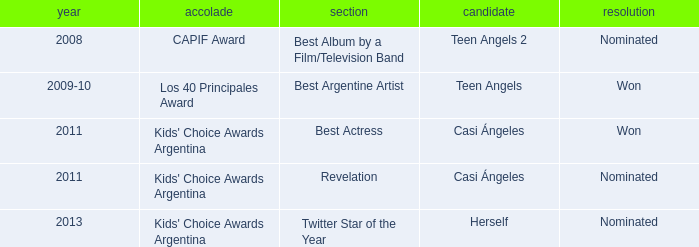Parse the table in full. {'header': ['year', 'accolade', 'section', 'candidate', 'resolution'], 'rows': [['2008', 'CAPIF Award', 'Best Album by a Film/Television Band', 'Teen Angels 2', 'Nominated'], ['2009-10', 'Los 40 Principales Award', 'Best Argentine Artist', 'Teen Angels', 'Won'], ['2011', "Kids' Choice Awards Argentina", 'Best Actress', 'Casi Ángeles', 'Won'], ['2011', "Kids' Choice Awards Argentina", 'Revelation', 'Casi Ángeles', 'Nominated'], ['2013', "Kids' Choice Awards Argentina", 'Twitter Star of the Year', 'Herself', 'Nominated']]} In which year was a best actress nomination given at the kids' choice awards argentina? 2011.0. 